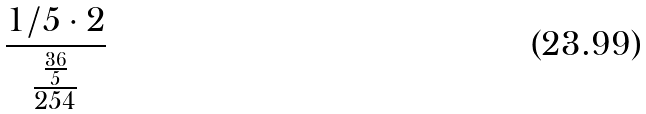Convert formula to latex. <formula><loc_0><loc_0><loc_500><loc_500>\frac { 1 / 5 \cdot 2 } { \frac { \frac { 3 6 } { 5 } } { 2 5 4 } }</formula> 